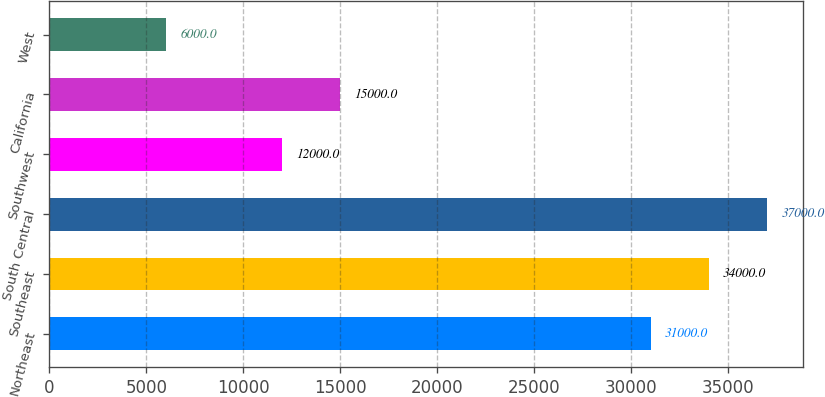Convert chart to OTSL. <chart><loc_0><loc_0><loc_500><loc_500><bar_chart><fcel>Northeast<fcel>Southeast<fcel>South Central<fcel>Southwest<fcel>California<fcel>West<nl><fcel>31000<fcel>34000<fcel>37000<fcel>12000<fcel>15000<fcel>6000<nl></chart> 